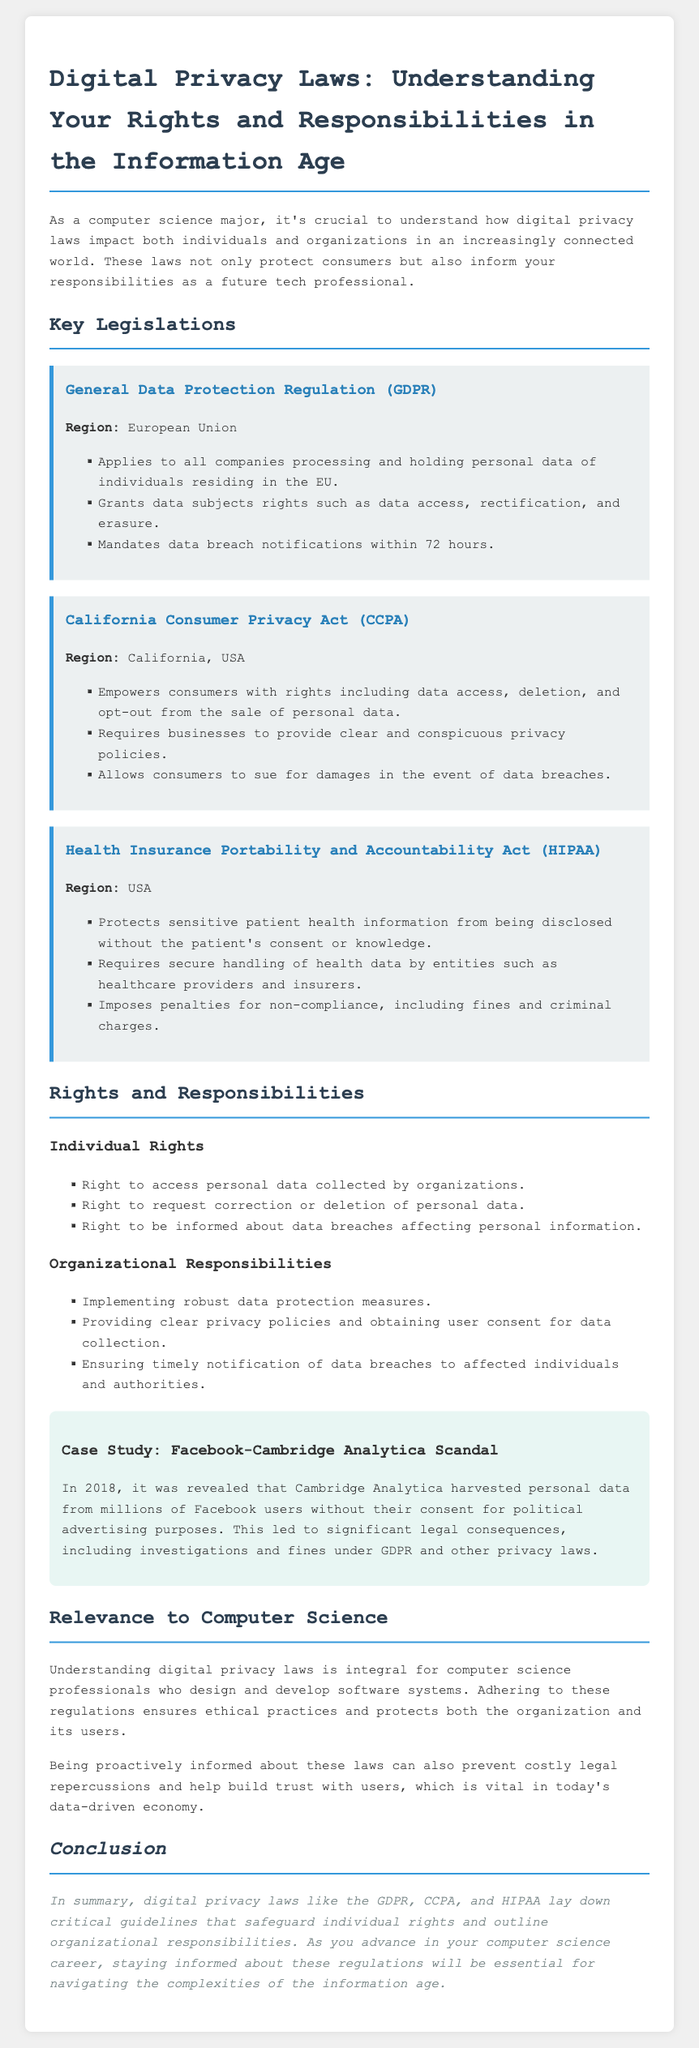What law applies to companies in the European Union processing personal data? The legislation that applies is the General Data Protection Regulation (GDPR), which governs the processing of personal data of individuals residing in the EU.
Answer: General Data Protection Regulation (GDPR) What rights does the CCPA grant consumers? The California Consumer Privacy Act (CCPA) empowers consumers with rights including data access, deletion, and the option to opt-out from the sale of personal data.
Answer: Data access, deletion, opt-out What is the required notification period for data breaches under GDPR? The GDPR mandates that data breach notifications must be made within a specific time frame to protect individual rights.
Answer: 72 hours Which organization is responsible for handling health data under HIPAA? The HIPAA legislation specifies certain entities, such as healthcare providers, that must secure sensitive patient health information.
Answer: Healthcare providers What was a significant consequence of the Facebook-Cambridge Analytica scandal? The case study mentions significant legal consequences, including investigations and fines, related to privacy laws.
Answer: Investigations and fines How does understanding digital privacy laws impact computer science professionals? Knowledge of these laws ensures ethical practices and safeguards both organizations and users in data handling procedures.
Answer: Ethical practices What must organizations do regarding privacy policies as stated in the rights and responsibilities section? The document outlines that organizations are required to provide clear and conspicuous privacy policies and must obtain user consent for collecting data.
Answer: Provide clear privacy policies What is the overall conclusion regarding digital privacy laws? The conclusion summarizes that digital privacy laws are vital for protecting individual rights and outlining organizational responsibilities in the information age.
Answer: Safeguard individual rights and outline responsibilities 